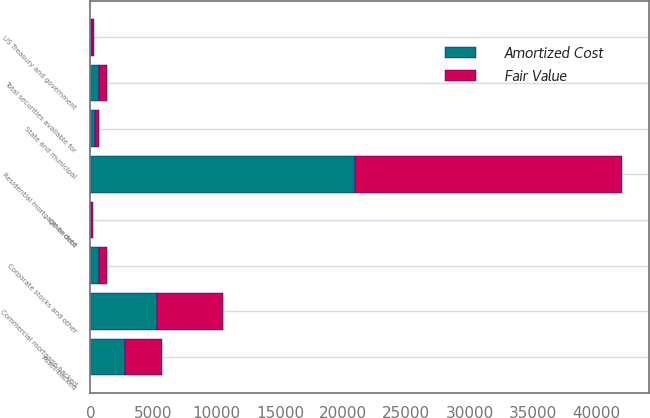<chart> <loc_0><loc_0><loc_500><loc_500><stacked_bar_chart><ecel><fcel>Residential mortgage-backed<fcel>Commercial mortgage-backed<fcel>Asset-backed<fcel>US Treasury and government<fcel>State and municipal<fcel>Other debt<fcel>Corporate stocks and other<fcel>Total securities available for<nl><fcel>Fair Value<fcel>21147<fcel>5227<fcel>2878<fcel>151<fcel>340<fcel>85<fcel>662<fcel>663<nl><fcel>Amortized Cost<fcel>20952<fcel>5264<fcel>2770<fcel>155<fcel>336<fcel>84<fcel>664<fcel>663<nl></chart> 